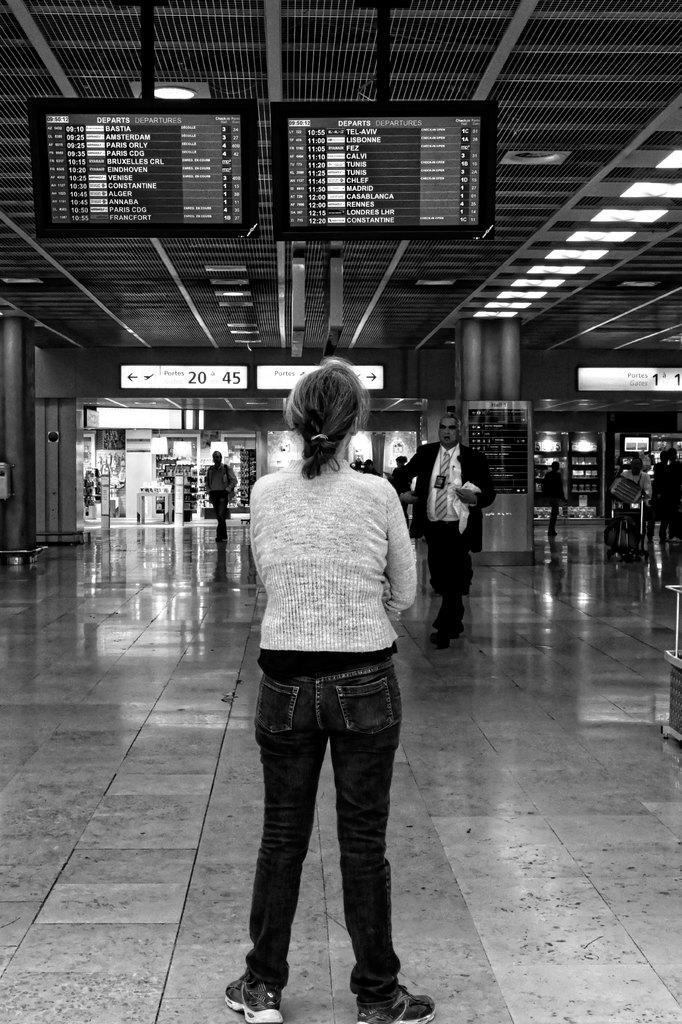Can you describe this image briefly? In the middle of the image there is a lady standing on the floor. In front of the lady there are stores and few people are walking. Also there are pillars and sign boards with light. At the top of the image there are screens. Also at the top of the image there is a roof with lights. At the right corner of the image there are stores and pillars. 